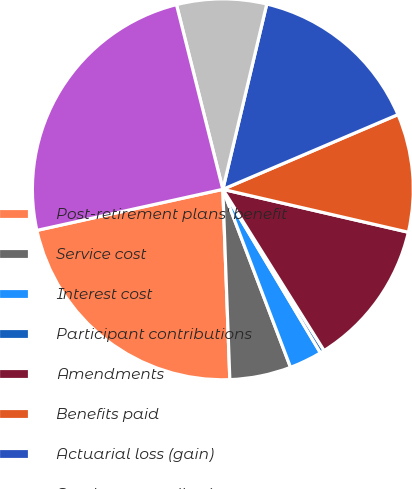<chart> <loc_0><loc_0><loc_500><loc_500><pie_chart><fcel>Post-retirement plans' benefit<fcel>Service cost<fcel>Interest cost<fcel>Participant contributions<fcel>Amendments<fcel>Benefits paid<fcel>Actuarial loss (gain)<fcel>Employer contributions<fcel>Under-funded balance<nl><fcel>22.13%<fcel>5.2%<fcel>2.78%<fcel>0.36%<fcel>12.46%<fcel>10.04%<fcel>14.88%<fcel>7.62%<fcel>24.55%<nl></chart> 